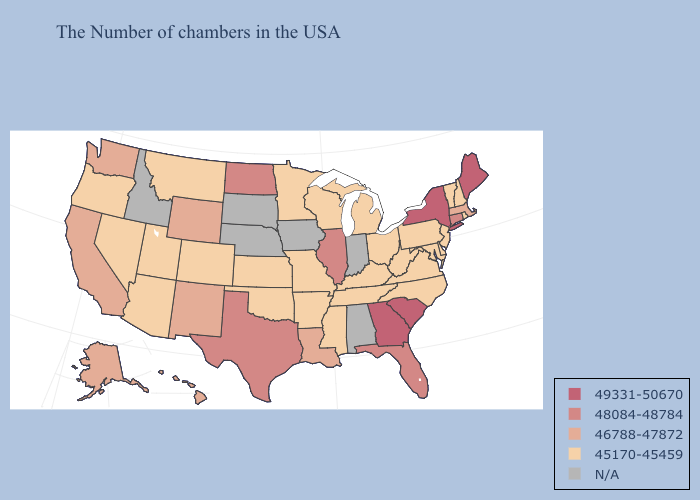Which states have the lowest value in the USA?
Short answer required. Rhode Island, New Hampshire, Vermont, New Jersey, Delaware, Maryland, Pennsylvania, Virginia, North Carolina, West Virginia, Ohio, Michigan, Kentucky, Tennessee, Wisconsin, Mississippi, Missouri, Arkansas, Minnesota, Kansas, Oklahoma, Colorado, Utah, Montana, Arizona, Nevada, Oregon. What is the value of California?
Quick response, please. 46788-47872. What is the lowest value in the South?
Keep it brief. 45170-45459. Does the map have missing data?
Short answer required. Yes. Does Nevada have the highest value in the West?
Concise answer only. No. What is the value of Maryland?
Keep it brief. 45170-45459. What is the value of Virginia?
Answer briefly. 45170-45459. Name the states that have a value in the range 48084-48784?
Quick response, please. Connecticut, Florida, Illinois, Texas, North Dakota. What is the highest value in states that border North Dakota?
Answer briefly. 45170-45459. Does Maine have the lowest value in the Northeast?
Write a very short answer. No. Which states have the highest value in the USA?
Give a very brief answer. Maine, New York, South Carolina, Georgia. Does Virginia have the lowest value in the South?
Quick response, please. Yes. 